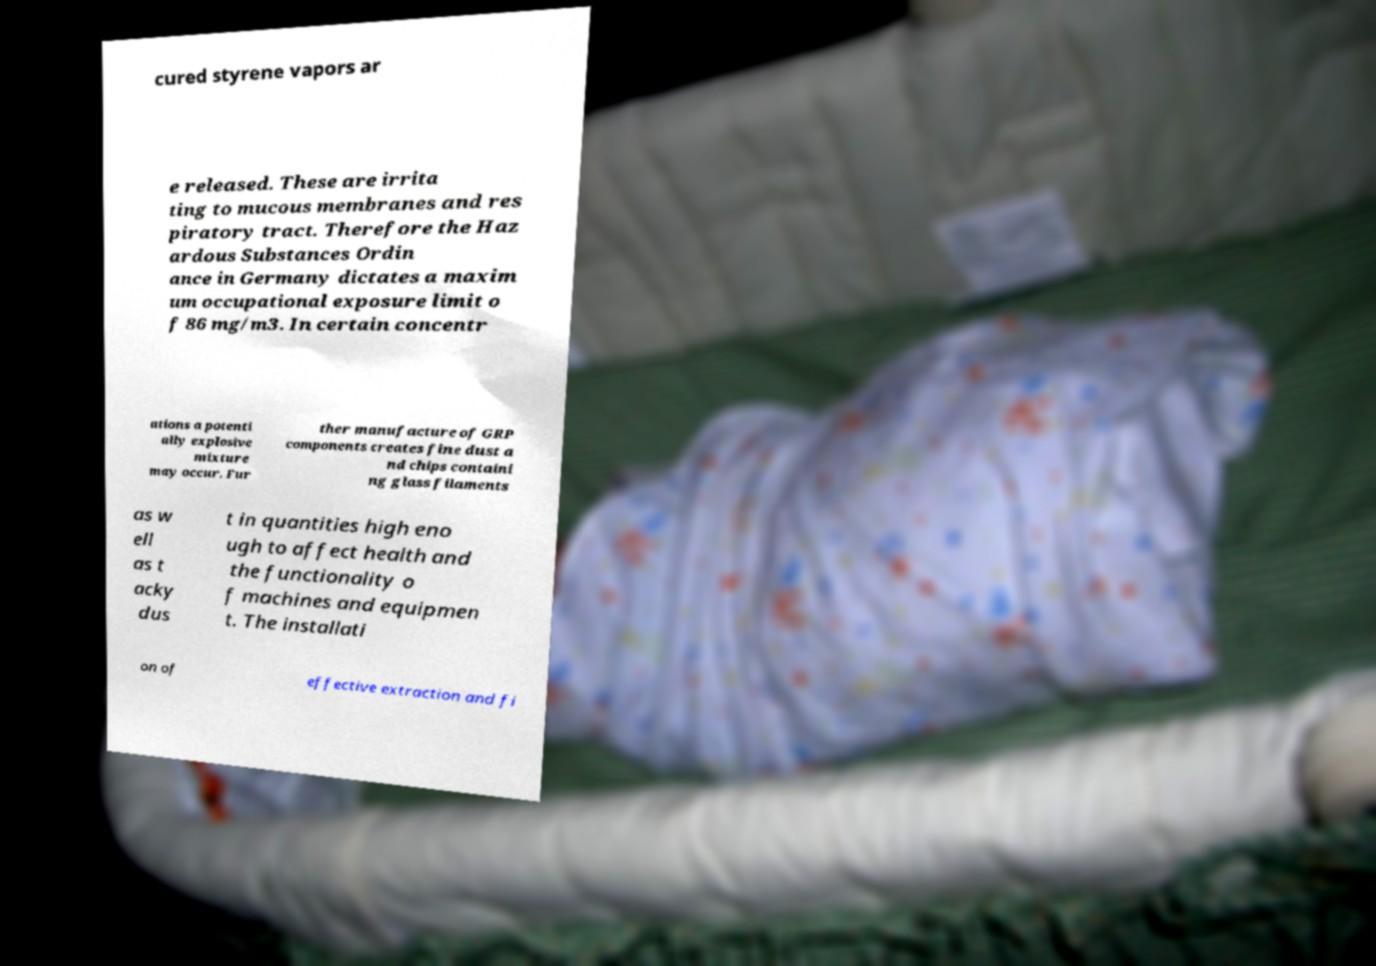For documentation purposes, I need the text within this image transcribed. Could you provide that? cured styrene vapors ar e released. These are irrita ting to mucous membranes and res piratory tract. Therefore the Haz ardous Substances Ordin ance in Germany dictates a maxim um occupational exposure limit o f 86 mg/m3. In certain concentr ations a potenti ally explosive mixture may occur. Fur ther manufacture of GRP components creates fine dust a nd chips containi ng glass filaments as w ell as t acky dus t in quantities high eno ugh to affect health and the functionality o f machines and equipmen t. The installati on of effective extraction and fi 